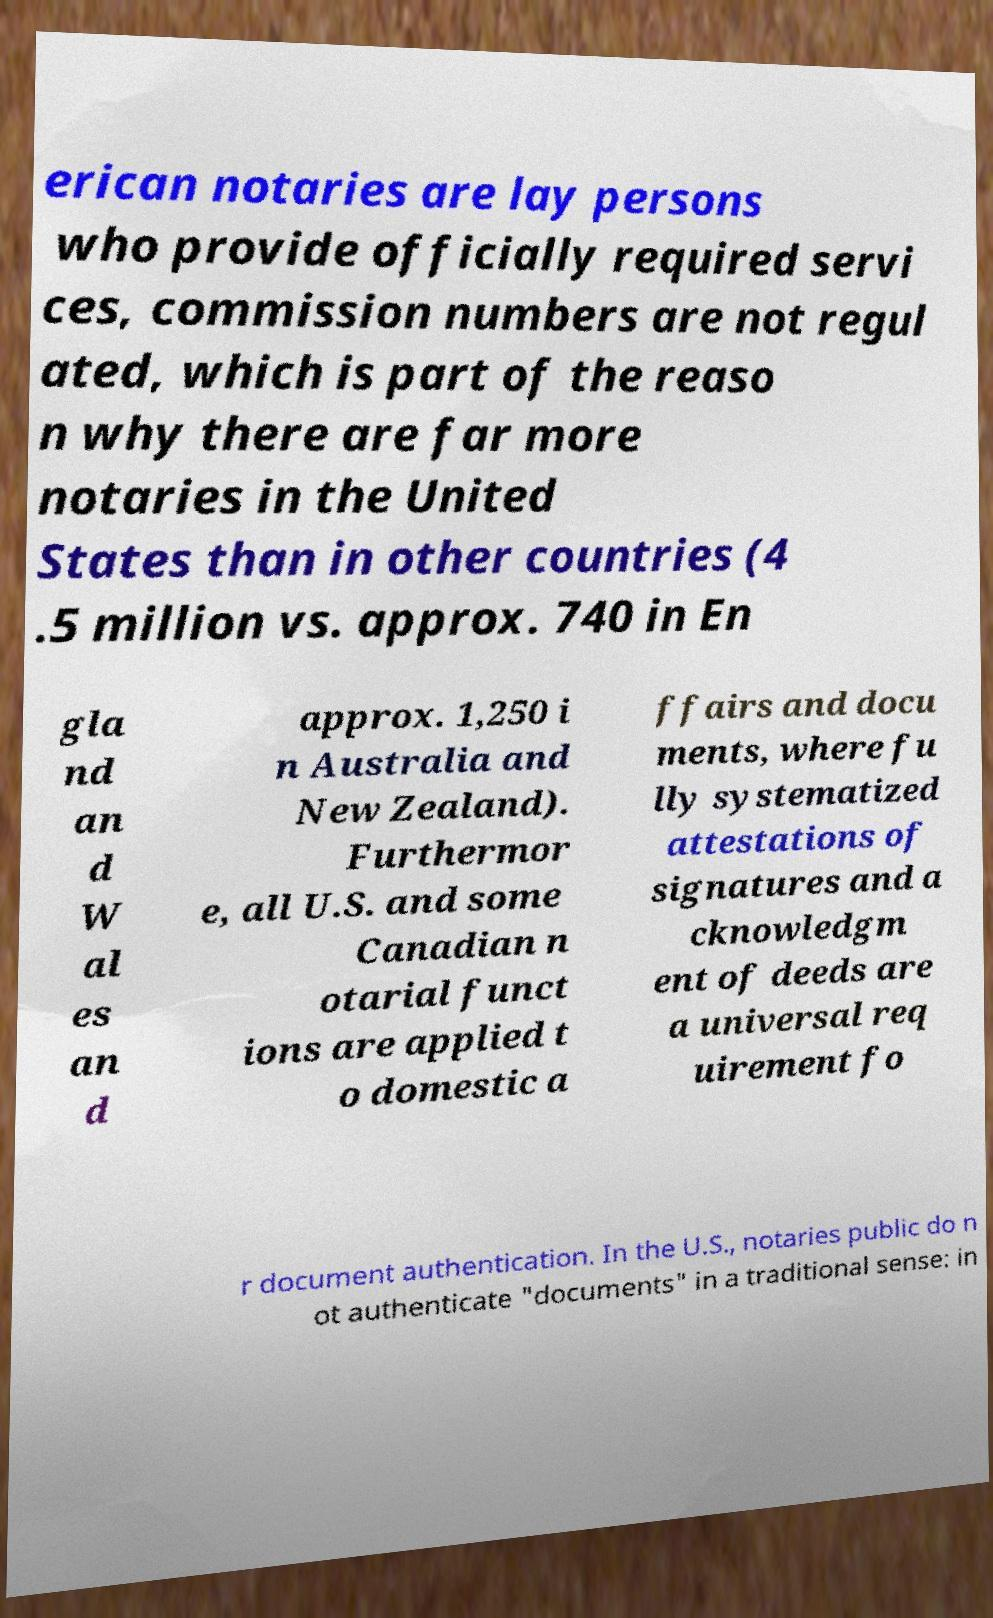Could you extract and type out the text from this image? erican notaries are lay persons who provide officially required servi ces, commission numbers are not regul ated, which is part of the reaso n why there are far more notaries in the United States than in other countries (4 .5 million vs. approx. 740 in En gla nd an d W al es an d approx. 1,250 i n Australia and New Zealand). Furthermor e, all U.S. and some Canadian n otarial funct ions are applied t o domestic a ffairs and docu ments, where fu lly systematized attestations of signatures and a cknowledgm ent of deeds are a universal req uirement fo r document authentication. In the U.S., notaries public do n ot authenticate "documents" in a traditional sense: in 